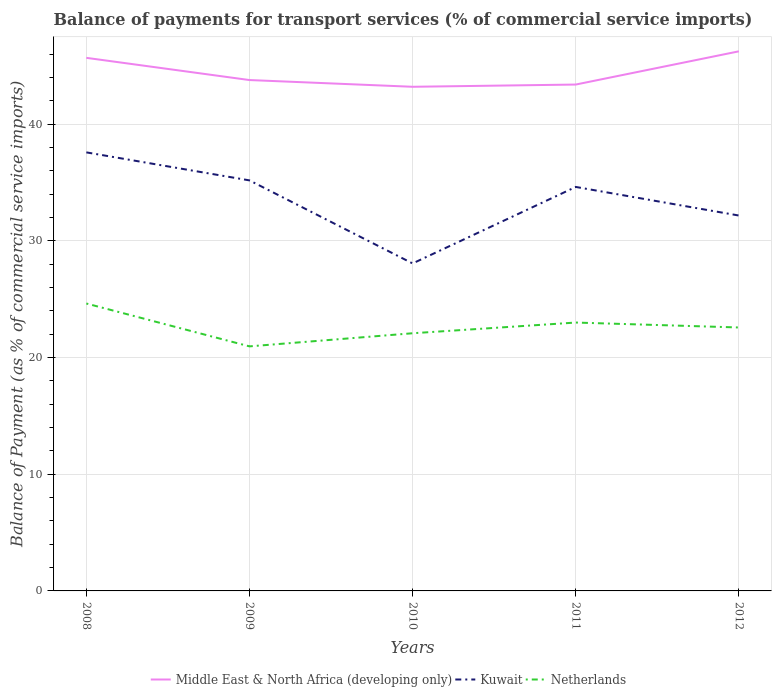How many different coloured lines are there?
Offer a terse response. 3. Is the number of lines equal to the number of legend labels?
Provide a succinct answer. Yes. Across all years, what is the maximum balance of payments for transport services in Kuwait?
Your response must be concise. 28.07. What is the total balance of payments for transport services in Middle East & North Africa (developing only) in the graph?
Provide a short and direct response. -3.04. What is the difference between the highest and the second highest balance of payments for transport services in Netherlands?
Your answer should be compact. 3.67. Is the balance of payments for transport services in Netherlands strictly greater than the balance of payments for transport services in Kuwait over the years?
Make the answer very short. Yes. What is the difference between two consecutive major ticks on the Y-axis?
Provide a short and direct response. 10. Does the graph contain grids?
Ensure brevity in your answer.  Yes. Where does the legend appear in the graph?
Offer a very short reply. Bottom center. How many legend labels are there?
Provide a short and direct response. 3. What is the title of the graph?
Offer a terse response. Balance of payments for transport services (% of commercial service imports). Does "Puerto Rico" appear as one of the legend labels in the graph?
Provide a short and direct response. No. What is the label or title of the Y-axis?
Offer a terse response. Balance of Payment (as % of commercial service imports). What is the Balance of Payment (as % of commercial service imports) in Middle East & North Africa (developing only) in 2008?
Your response must be concise. 45.69. What is the Balance of Payment (as % of commercial service imports) in Kuwait in 2008?
Offer a very short reply. 37.59. What is the Balance of Payment (as % of commercial service imports) of Netherlands in 2008?
Offer a very short reply. 24.63. What is the Balance of Payment (as % of commercial service imports) in Middle East & North Africa (developing only) in 2009?
Keep it short and to the point. 43.78. What is the Balance of Payment (as % of commercial service imports) in Kuwait in 2009?
Your answer should be very brief. 35.19. What is the Balance of Payment (as % of commercial service imports) in Netherlands in 2009?
Ensure brevity in your answer.  20.96. What is the Balance of Payment (as % of commercial service imports) in Middle East & North Africa (developing only) in 2010?
Make the answer very short. 43.21. What is the Balance of Payment (as % of commercial service imports) of Kuwait in 2010?
Ensure brevity in your answer.  28.07. What is the Balance of Payment (as % of commercial service imports) of Netherlands in 2010?
Your answer should be very brief. 22.08. What is the Balance of Payment (as % of commercial service imports) of Middle East & North Africa (developing only) in 2011?
Make the answer very short. 43.4. What is the Balance of Payment (as % of commercial service imports) in Kuwait in 2011?
Your response must be concise. 34.62. What is the Balance of Payment (as % of commercial service imports) of Netherlands in 2011?
Give a very brief answer. 23. What is the Balance of Payment (as % of commercial service imports) in Middle East & North Africa (developing only) in 2012?
Provide a short and direct response. 46.25. What is the Balance of Payment (as % of commercial service imports) of Kuwait in 2012?
Ensure brevity in your answer.  32.17. What is the Balance of Payment (as % of commercial service imports) in Netherlands in 2012?
Keep it short and to the point. 22.58. Across all years, what is the maximum Balance of Payment (as % of commercial service imports) of Middle East & North Africa (developing only)?
Provide a short and direct response. 46.25. Across all years, what is the maximum Balance of Payment (as % of commercial service imports) in Kuwait?
Your answer should be compact. 37.59. Across all years, what is the maximum Balance of Payment (as % of commercial service imports) of Netherlands?
Your response must be concise. 24.63. Across all years, what is the minimum Balance of Payment (as % of commercial service imports) of Middle East & North Africa (developing only)?
Provide a short and direct response. 43.21. Across all years, what is the minimum Balance of Payment (as % of commercial service imports) of Kuwait?
Your answer should be compact. 28.07. Across all years, what is the minimum Balance of Payment (as % of commercial service imports) of Netherlands?
Your answer should be very brief. 20.96. What is the total Balance of Payment (as % of commercial service imports) in Middle East & North Africa (developing only) in the graph?
Offer a very short reply. 222.32. What is the total Balance of Payment (as % of commercial service imports) of Kuwait in the graph?
Provide a succinct answer. 167.63. What is the total Balance of Payment (as % of commercial service imports) of Netherlands in the graph?
Provide a succinct answer. 113.26. What is the difference between the Balance of Payment (as % of commercial service imports) in Middle East & North Africa (developing only) in 2008 and that in 2009?
Offer a very short reply. 1.9. What is the difference between the Balance of Payment (as % of commercial service imports) of Kuwait in 2008 and that in 2009?
Provide a short and direct response. 2.4. What is the difference between the Balance of Payment (as % of commercial service imports) of Netherlands in 2008 and that in 2009?
Give a very brief answer. 3.67. What is the difference between the Balance of Payment (as % of commercial service imports) of Middle East & North Africa (developing only) in 2008 and that in 2010?
Provide a succinct answer. 2.48. What is the difference between the Balance of Payment (as % of commercial service imports) in Kuwait in 2008 and that in 2010?
Offer a very short reply. 9.52. What is the difference between the Balance of Payment (as % of commercial service imports) of Netherlands in 2008 and that in 2010?
Your answer should be very brief. 2.55. What is the difference between the Balance of Payment (as % of commercial service imports) of Middle East & North Africa (developing only) in 2008 and that in 2011?
Make the answer very short. 2.29. What is the difference between the Balance of Payment (as % of commercial service imports) in Kuwait in 2008 and that in 2011?
Offer a terse response. 2.96. What is the difference between the Balance of Payment (as % of commercial service imports) of Netherlands in 2008 and that in 2011?
Provide a short and direct response. 1.63. What is the difference between the Balance of Payment (as % of commercial service imports) of Middle East & North Africa (developing only) in 2008 and that in 2012?
Keep it short and to the point. -0.56. What is the difference between the Balance of Payment (as % of commercial service imports) in Kuwait in 2008 and that in 2012?
Offer a terse response. 5.41. What is the difference between the Balance of Payment (as % of commercial service imports) in Netherlands in 2008 and that in 2012?
Provide a short and direct response. 2.05. What is the difference between the Balance of Payment (as % of commercial service imports) of Middle East & North Africa (developing only) in 2009 and that in 2010?
Make the answer very short. 0.58. What is the difference between the Balance of Payment (as % of commercial service imports) of Kuwait in 2009 and that in 2010?
Give a very brief answer. 7.12. What is the difference between the Balance of Payment (as % of commercial service imports) in Netherlands in 2009 and that in 2010?
Give a very brief answer. -1.12. What is the difference between the Balance of Payment (as % of commercial service imports) of Middle East & North Africa (developing only) in 2009 and that in 2011?
Your answer should be compact. 0.39. What is the difference between the Balance of Payment (as % of commercial service imports) of Kuwait in 2009 and that in 2011?
Provide a succinct answer. 0.56. What is the difference between the Balance of Payment (as % of commercial service imports) of Netherlands in 2009 and that in 2011?
Ensure brevity in your answer.  -2.04. What is the difference between the Balance of Payment (as % of commercial service imports) in Middle East & North Africa (developing only) in 2009 and that in 2012?
Provide a short and direct response. -2.46. What is the difference between the Balance of Payment (as % of commercial service imports) in Kuwait in 2009 and that in 2012?
Your answer should be compact. 3.01. What is the difference between the Balance of Payment (as % of commercial service imports) of Netherlands in 2009 and that in 2012?
Keep it short and to the point. -1.62. What is the difference between the Balance of Payment (as % of commercial service imports) in Middle East & North Africa (developing only) in 2010 and that in 2011?
Offer a terse response. -0.19. What is the difference between the Balance of Payment (as % of commercial service imports) in Kuwait in 2010 and that in 2011?
Your answer should be compact. -6.56. What is the difference between the Balance of Payment (as % of commercial service imports) in Netherlands in 2010 and that in 2011?
Ensure brevity in your answer.  -0.92. What is the difference between the Balance of Payment (as % of commercial service imports) of Middle East & North Africa (developing only) in 2010 and that in 2012?
Keep it short and to the point. -3.04. What is the difference between the Balance of Payment (as % of commercial service imports) of Kuwait in 2010 and that in 2012?
Offer a terse response. -4.11. What is the difference between the Balance of Payment (as % of commercial service imports) of Netherlands in 2010 and that in 2012?
Offer a very short reply. -0.49. What is the difference between the Balance of Payment (as % of commercial service imports) in Middle East & North Africa (developing only) in 2011 and that in 2012?
Provide a succinct answer. -2.85. What is the difference between the Balance of Payment (as % of commercial service imports) of Kuwait in 2011 and that in 2012?
Offer a very short reply. 2.45. What is the difference between the Balance of Payment (as % of commercial service imports) in Netherlands in 2011 and that in 2012?
Provide a succinct answer. 0.42. What is the difference between the Balance of Payment (as % of commercial service imports) in Middle East & North Africa (developing only) in 2008 and the Balance of Payment (as % of commercial service imports) in Kuwait in 2009?
Offer a terse response. 10.5. What is the difference between the Balance of Payment (as % of commercial service imports) of Middle East & North Africa (developing only) in 2008 and the Balance of Payment (as % of commercial service imports) of Netherlands in 2009?
Keep it short and to the point. 24.73. What is the difference between the Balance of Payment (as % of commercial service imports) of Kuwait in 2008 and the Balance of Payment (as % of commercial service imports) of Netherlands in 2009?
Make the answer very short. 16.63. What is the difference between the Balance of Payment (as % of commercial service imports) in Middle East & North Africa (developing only) in 2008 and the Balance of Payment (as % of commercial service imports) in Kuwait in 2010?
Ensure brevity in your answer.  17.62. What is the difference between the Balance of Payment (as % of commercial service imports) of Middle East & North Africa (developing only) in 2008 and the Balance of Payment (as % of commercial service imports) of Netherlands in 2010?
Make the answer very short. 23.6. What is the difference between the Balance of Payment (as % of commercial service imports) in Kuwait in 2008 and the Balance of Payment (as % of commercial service imports) in Netherlands in 2010?
Provide a succinct answer. 15.5. What is the difference between the Balance of Payment (as % of commercial service imports) of Middle East & North Africa (developing only) in 2008 and the Balance of Payment (as % of commercial service imports) of Kuwait in 2011?
Provide a short and direct response. 11.07. What is the difference between the Balance of Payment (as % of commercial service imports) in Middle East & North Africa (developing only) in 2008 and the Balance of Payment (as % of commercial service imports) in Netherlands in 2011?
Give a very brief answer. 22.69. What is the difference between the Balance of Payment (as % of commercial service imports) of Kuwait in 2008 and the Balance of Payment (as % of commercial service imports) of Netherlands in 2011?
Your response must be concise. 14.58. What is the difference between the Balance of Payment (as % of commercial service imports) of Middle East & North Africa (developing only) in 2008 and the Balance of Payment (as % of commercial service imports) of Kuwait in 2012?
Give a very brief answer. 13.52. What is the difference between the Balance of Payment (as % of commercial service imports) in Middle East & North Africa (developing only) in 2008 and the Balance of Payment (as % of commercial service imports) in Netherlands in 2012?
Provide a short and direct response. 23.11. What is the difference between the Balance of Payment (as % of commercial service imports) of Kuwait in 2008 and the Balance of Payment (as % of commercial service imports) of Netherlands in 2012?
Your response must be concise. 15.01. What is the difference between the Balance of Payment (as % of commercial service imports) in Middle East & North Africa (developing only) in 2009 and the Balance of Payment (as % of commercial service imports) in Kuwait in 2010?
Provide a succinct answer. 15.72. What is the difference between the Balance of Payment (as % of commercial service imports) of Middle East & North Africa (developing only) in 2009 and the Balance of Payment (as % of commercial service imports) of Netherlands in 2010?
Ensure brevity in your answer.  21.7. What is the difference between the Balance of Payment (as % of commercial service imports) in Kuwait in 2009 and the Balance of Payment (as % of commercial service imports) in Netherlands in 2010?
Provide a succinct answer. 13.1. What is the difference between the Balance of Payment (as % of commercial service imports) of Middle East & North Africa (developing only) in 2009 and the Balance of Payment (as % of commercial service imports) of Kuwait in 2011?
Offer a terse response. 9.16. What is the difference between the Balance of Payment (as % of commercial service imports) of Middle East & North Africa (developing only) in 2009 and the Balance of Payment (as % of commercial service imports) of Netherlands in 2011?
Your answer should be very brief. 20.78. What is the difference between the Balance of Payment (as % of commercial service imports) in Kuwait in 2009 and the Balance of Payment (as % of commercial service imports) in Netherlands in 2011?
Offer a very short reply. 12.18. What is the difference between the Balance of Payment (as % of commercial service imports) of Middle East & North Africa (developing only) in 2009 and the Balance of Payment (as % of commercial service imports) of Kuwait in 2012?
Make the answer very short. 11.61. What is the difference between the Balance of Payment (as % of commercial service imports) in Middle East & North Africa (developing only) in 2009 and the Balance of Payment (as % of commercial service imports) in Netherlands in 2012?
Your answer should be very brief. 21.21. What is the difference between the Balance of Payment (as % of commercial service imports) of Kuwait in 2009 and the Balance of Payment (as % of commercial service imports) of Netherlands in 2012?
Give a very brief answer. 12.61. What is the difference between the Balance of Payment (as % of commercial service imports) of Middle East & North Africa (developing only) in 2010 and the Balance of Payment (as % of commercial service imports) of Kuwait in 2011?
Offer a very short reply. 8.58. What is the difference between the Balance of Payment (as % of commercial service imports) in Middle East & North Africa (developing only) in 2010 and the Balance of Payment (as % of commercial service imports) in Netherlands in 2011?
Offer a very short reply. 20.21. What is the difference between the Balance of Payment (as % of commercial service imports) in Kuwait in 2010 and the Balance of Payment (as % of commercial service imports) in Netherlands in 2011?
Ensure brevity in your answer.  5.07. What is the difference between the Balance of Payment (as % of commercial service imports) of Middle East & North Africa (developing only) in 2010 and the Balance of Payment (as % of commercial service imports) of Kuwait in 2012?
Make the answer very short. 11.03. What is the difference between the Balance of Payment (as % of commercial service imports) of Middle East & North Africa (developing only) in 2010 and the Balance of Payment (as % of commercial service imports) of Netherlands in 2012?
Offer a terse response. 20.63. What is the difference between the Balance of Payment (as % of commercial service imports) in Kuwait in 2010 and the Balance of Payment (as % of commercial service imports) in Netherlands in 2012?
Provide a short and direct response. 5.49. What is the difference between the Balance of Payment (as % of commercial service imports) in Middle East & North Africa (developing only) in 2011 and the Balance of Payment (as % of commercial service imports) in Kuwait in 2012?
Your answer should be compact. 11.23. What is the difference between the Balance of Payment (as % of commercial service imports) in Middle East & North Africa (developing only) in 2011 and the Balance of Payment (as % of commercial service imports) in Netherlands in 2012?
Offer a very short reply. 20.82. What is the difference between the Balance of Payment (as % of commercial service imports) in Kuwait in 2011 and the Balance of Payment (as % of commercial service imports) in Netherlands in 2012?
Ensure brevity in your answer.  12.04. What is the average Balance of Payment (as % of commercial service imports) in Middle East & North Africa (developing only) per year?
Offer a very short reply. 44.46. What is the average Balance of Payment (as % of commercial service imports) of Kuwait per year?
Make the answer very short. 33.53. What is the average Balance of Payment (as % of commercial service imports) of Netherlands per year?
Provide a short and direct response. 22.65. In the year 2008, what is the difference between the Balance of Payment (as % of commercial service imports) in Middle East & North Africa (developing only) and Balance of Payment (as % of commercial service imports) in Kuwait?
Offer a terse response. 8.1. In the year 2008, what is the difference between the Balance of Payment (as % of commercial service imports) of Middle East & North Africa (developing only) and Balance of Payment (as % of commercial service imports) of Netherlands?
Provide a succinct answer. 21.06. In the year 2008, what is the difference between the Balance of Payment (as % of commercial service imports) in Kuwait and Balance of Payment (as % of commercial service imports) in Netherlands?
Make the answer very short. 12.95. In the year 2009, what is the difference between the Balance of Payment (as % of commercial service imports) of Middle East & North Africa (developing only) and Balance of Payment (as % of commercial service imports) of Kuwait?
Offer a very short reply. 8.6. In the year 2009, what is the difference between the Balance of Payment (as % of commercial service imports) of Middle East & North Africa (developing only) and Balance of Payment (as % of commercial service imports) of Netherlands?
Give a very brief answer. 22.82. In the year 2009, what is the difference between the Balance of Payment (as % of commercial service imports) in Kuwait and Balance of Payment (as % of commercial service imports) in Netherlands?
Make the answer very short. 14.23. In the year 2010, what is the difference between the Balance of Payment (as % of commercial service imports) in Middle East & North Africa (developing only) and Balance of Payment (as % of commercial service imports) in Kuwait?
Your answer should be very brief. 15.14. In the year 2010, what is the difference between the Balance of Payment (as % of commercial service imports) in Middle East & North Africa (developing only) and Balance of Payment (as % of commercial service imports) in Netherlands?
Offer a very short reply. 21.12. In the year 2010, what is the difference between the Balance of Payment (as % of commercial service imports) in Kuwait and Balance of Payment (as % of commercial service imports) in Netherlands?
Make the answer very short. 5.98. In the year 2011, what is the difference between the Balance of Payment (as % of commercial service imports) of Middle East & North Africa (developing only) and Balance of Payment (as % of commercial service imports) of Kuwait?
Your answer should be compact. 8.78. In the year 2011, what is the difference between the Balance of Payment (as % of commercial service imports) of Middle East & North Africa (developing only) and Balance of Payment (as % of commercial service imports) of Netherlands?
Offer a terse response. 20.4. In the year 2011, what is the difference between the Balance of Payment (as % of commercial service imports) in Kuwait and Balance of Payment (as % of commercial service imports) in Netherlands?
Provide a succinct answer. 11.62. In the year 2012, what is the difference between the Balance of Payment (as % of commercial service imports) in Middle East & North Africa (developing only) and Balance of Payment (as % of commercial service imports) in Kuwait?
Ensure brevity in your answer.  14.07. In the year 2012, what is the difference between the Balance of Payment (as % of commercial service imports) in Middle East & North Africa (developing only) and Balance of Payment (as % of commercial service imports) in Netherlands?
Give a very brief answer. 23.67. In the year 2012, what is the difference between the Balance of Payment (as % of commercial service imports) of Kuwait and Balance of Payment (as % of commercial service imports) of Netherlands?
Make the answer very short. 9.59. What is the ratio of the Balance of Payment (as % of commercial service imports) of Middle East & North Africa (developing only) in 2008 to that in 2009?
Ensure brevity in your answer.  1.04. What is the ratio of the Balance of Payment (as % of commercial service imports) in Kuwait in 2008 to that in 2009?
Give a very brief answer. 1.07. What is the ratio of the Balance of Payment (as % of commercial service imports) in Netherlands in 2008 to that in 2009?
Your answer should be very brief. 1.18. What is the ratio of the Balance of Payment (as % of commercial service imports) in Middle East & North Africa (developing only) in 2008 to that in 2010?
Your answer should be very brief. 1.06. What is the ratio of the Balance of Payment (as % of commercial service imports) of Kuwait in 2008 to that in 2010?
Give a very brief answer. 1.34. What is the ratio of the Balance of Payment (as % of commercial service imports) in Netherlands in 2008 to that in 2010?
Your response must be concise. 1.12. What is the ratio of the Balance of Payment (as % of commercial service imports) of Middle East & North Africa (developing only) in 2008 to that in 2011?
Provide a short and direct response. 1.05. What is the ratio of the Balance of Payment (as % of commercial service imports) in Kuwait in 2008 to that in 2011?
Keep it short and to the point. 1.09. What is the ratio of the Balance of Payment (as % of commercial service imports) of Netherlands in 2008 to that in 2011?
Offer a very short reply. 1.07. What is the ratio of the Balance of Payment (as % of commercial service imports) in Middle East & North Africa (developing only) in 2008 to that in 2012?
Provide a short and direct response. 0.99. What is the ratio of the Balance of Payment (as % of commercial service imports) in Kuwait in 2008 to that in 2012?
Your answer should be compact. 1.17. What is the ratio of the Balance of Payment (as % of commercial service imports) of Netherlands in 2008 to that in 2012?
Provide a short and direct response. 1.09. What is the ratio of the Balance of Payment (as % of commercial service imports) of Middle East & North Africa (developing only) in 2009 to that in 2010?
Your answer should be very brief. 1.01. What is the ratio of the Balance of Payment (as % of commercial service imports) in Kuwait in 2009 to that in 2010?
Provide a succinct answer. 1.25. What is the ratio of the Balance of Payment (as % of commercial service imports) of Netherlands in 2009 to that in 2010?
Provide a short and direct response. 0.95. What is the ratio of the Balance of Payment (as % of commercial service imports) in Middle East & North Africa (developing only) in 2009 to that in 2011?
Keep it short and to the point. 1.01. What is the ratio of the Balance of Payment (as % of commercial service imports) of Kuwait in 2009 to that in 2011?
Keep it short and to the point. 1.02. What is the ratio of the Balance of Payment (as % of commercial service imports) in Netherlands in 2009 to that in 2011?
Offer a very short reply. 0.91. What is the ratio of the Balance of Payment (as % of commercial service imports) in Middle East & North Africa (developing only) in 2009 to that in 2012?
Offer a terse response. 0.95. What is the ratio of the Balance of Payment (as % of commercial service imports) of Kuwait in 2009 to that in 2012?
Provide a short and direct response. 1.09. What is the ratio of the Balance of Payment (as % of commercial service imports) in Netherlands in 2009 to that in 2012?
Keep it short and to the point. 0.93. What is the ratio of the Balance of Payment (as % of commercial service imports) of Middle East & North Africa (developing only) in 2010 to that in 2011?
Your answer should be very brief. 1. What is the ratio of the Balance of Payment (as % of commercial service imports) of Kuwait in 2010 to that in 2011?
Make the answer very short. 0.81. What is the ratio of the Balance of Payment (as % of commercial service imports) in Netherlands in 2010 to that in 2011?
Keep it short and to the point. 0.96. What is the ratio of the Balance of Payment (as % of commercial service imports) in Middle East & North Africa (developing only) in 2010 to that in 2012?
Offer a terse response. 0.93. What is the ratio of the Balance of Payment (as % of commercial service imports) of Kuwait in 2010 to that in 2012?
Offer a very short reply. 0.87. What is the ratio of the Balance of Payment (as % of commercial service imports) of Netherlands in 2010 to that in 2012?
Give a very brief answer. 0.98. What is the ratio of the Balance of Payment (as % of commercial service imports) in Middle East & North Africa (developing only) in 2011 to that in 2012?
Your answer should be very brief. 0.94. What is the ratio of the Balance of Payment (as % of commercial service imports) in Kuwait in 2011 to that in 2012?
Your answer should be very brief. 1.08. What is the ratio of the Balance of Payment (as % of commercial service imports) in Netherlands in 2011 to that in 2012?
Make the answer very short. 1.02. What is the difference between the highest and the second highest Balance of Payment (as % of commercial service imports) in Middle East & North Africa (developing only)?
Give a very brief answer. 0.56. What is the difference between the highest and the second highest Balance of Payment (as % of commercial service imports) of Kuwait?
Make the answer very short. 2.4. What is the difference between the highest and the second highest Balance of Payment (as % of commercial service imports) of Netherlands?
Ensure brevity in your answer.  1.63. What is the difference between the highest and the lowest Balance of Payment (as % of commercial service imports) of Middle East & North Africa (developing only)?
Ensure brevity in your answer.  3.04. What is the difference between the highest and the lowest Balance of Payment (as % of commercial service imports) of Kuwait?
Give a very brief answer. 9.52. What is the difference between the highest and the lowest Balance of Payment (as % of commercial service imports) of Netherlands?
Keep it short and to the point. 3.67. 